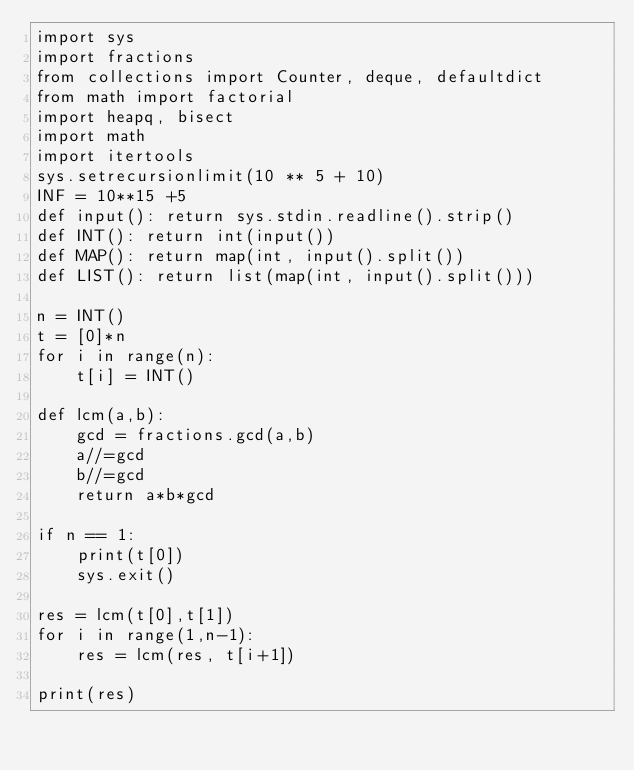Convert code to text. <code><loc_0><loc_0><loc_500><loc_500><_Python_>import sys
import fractions
from collections import Counter, deque, defaultdict
from math import factorial
import heapq, bisect
import math
import itertools
sys.setrecursionlimit(10 ** 5 + 10)
INF = 10**15 +5
def input(): return sys.stdin.readline().strip()
def INT(): return int(input())
def MAP(): return map(int, input().split())
def LIST(): return list(map(int, input().split()))

n = INT()
t = [0]*n
for i in range(n):
    t[i] = INT()

def lcm(a,b):
    gcd = fractions.gcd(a,b)
    a//=gcd
    b//=gcd
    return a*b*gcd
    
if n == 1:
    print(t[0])
    sys.exit()

res = lcm(t[0],t[1])
for i in range(1,n-1):
    res = lcm(res, t[i+1])

print(res)


</code> 